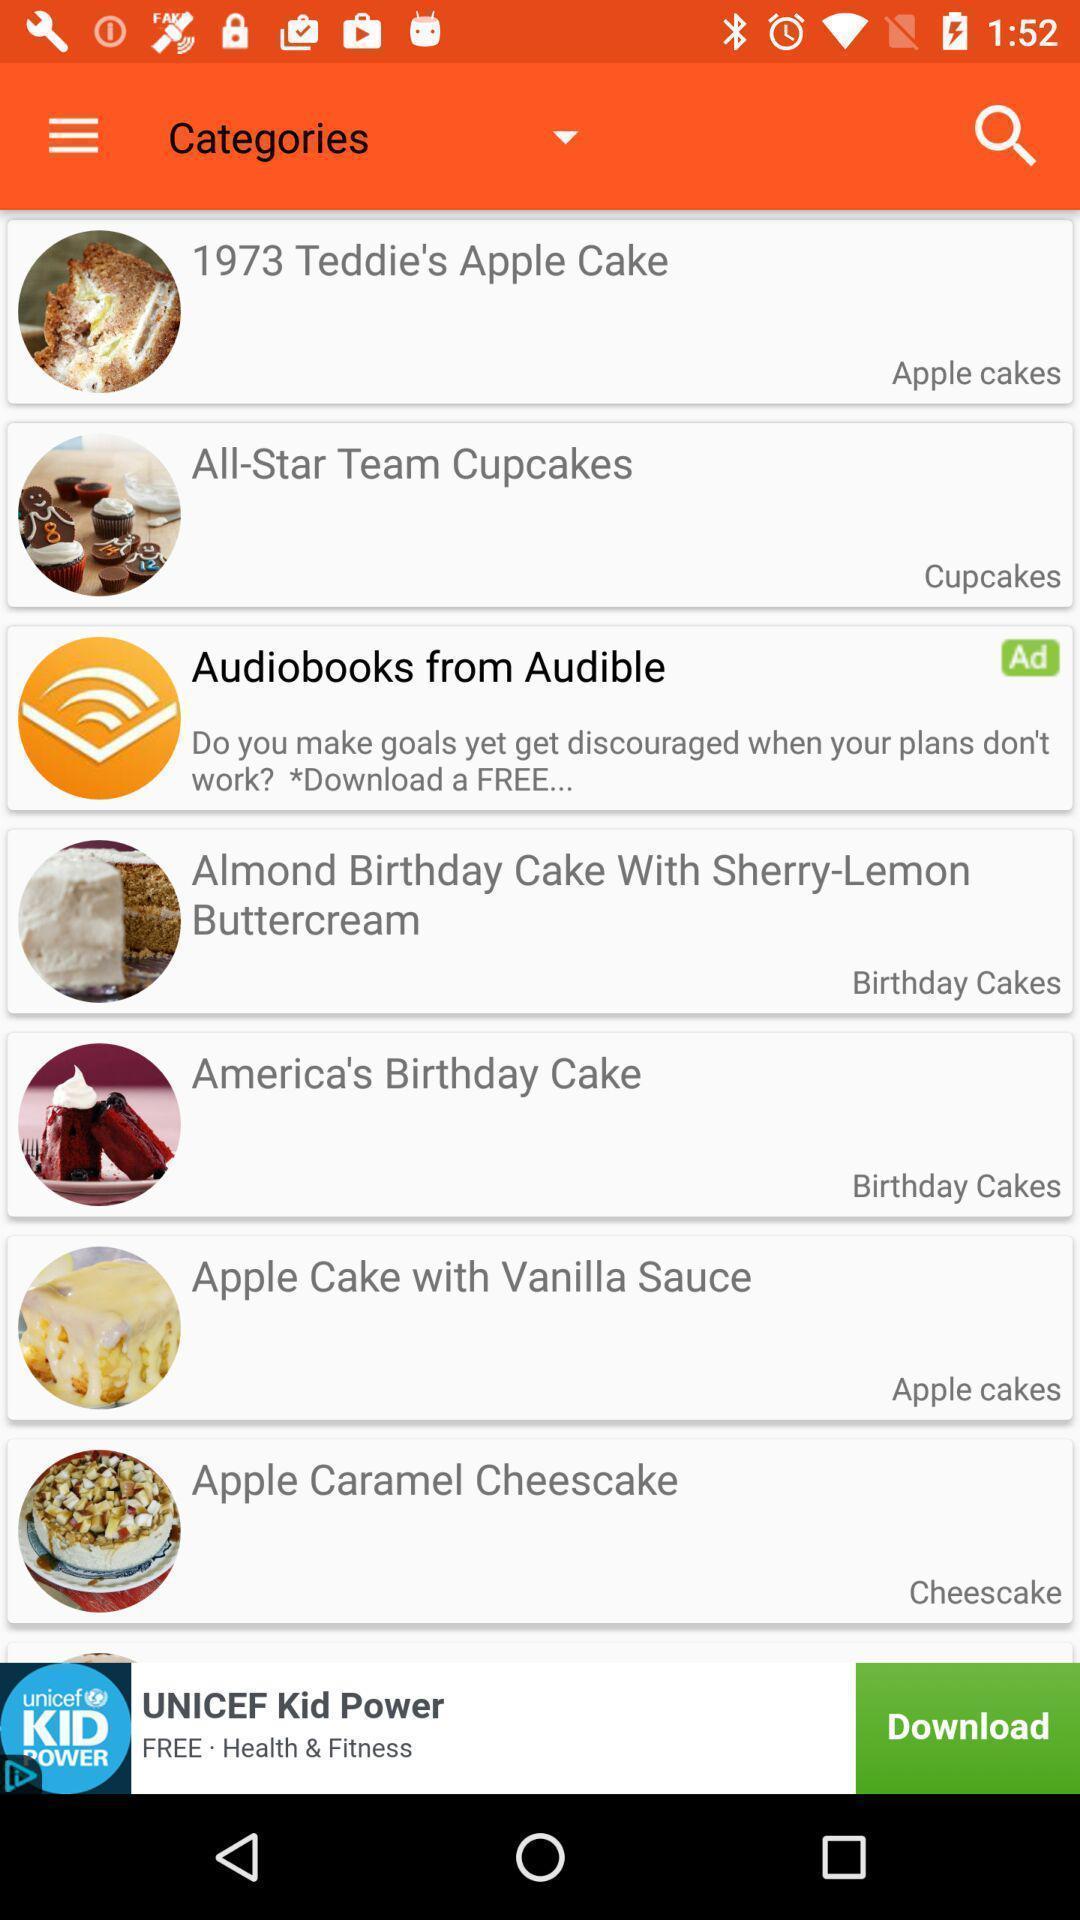Provide a detailed account of this screenshot. Screen displaying a search icon and list of cake names. 